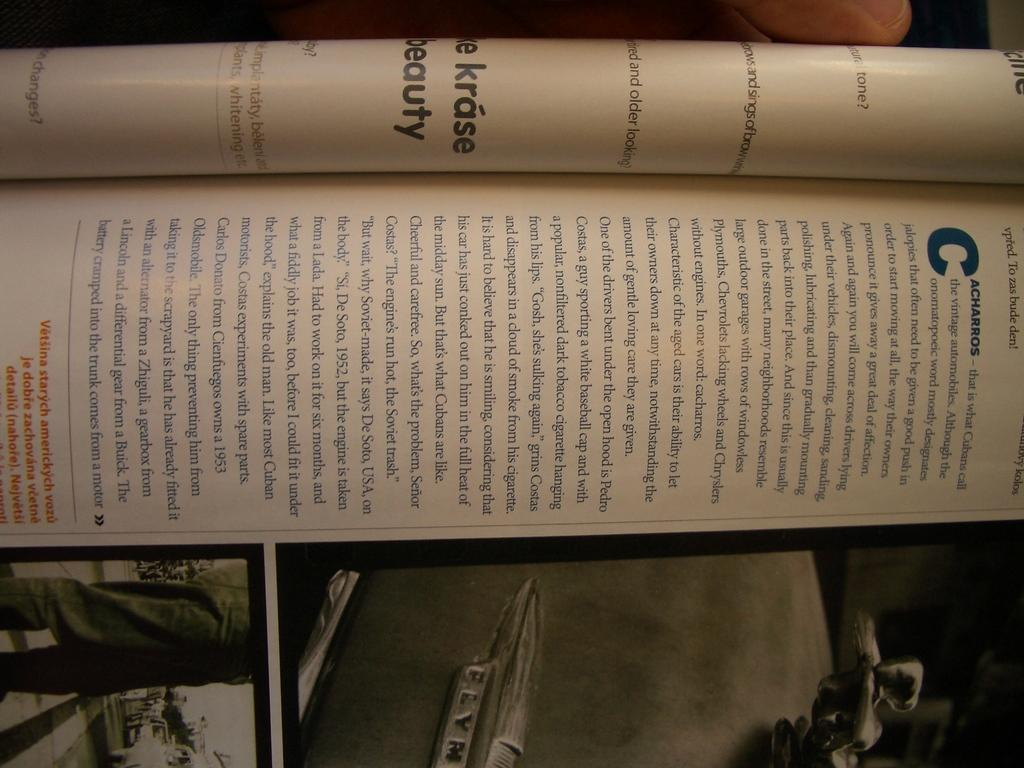Provide a one-sentence caption for the provided image. A sideways on snapshot of a magazine, the writing in which is too small to read. 